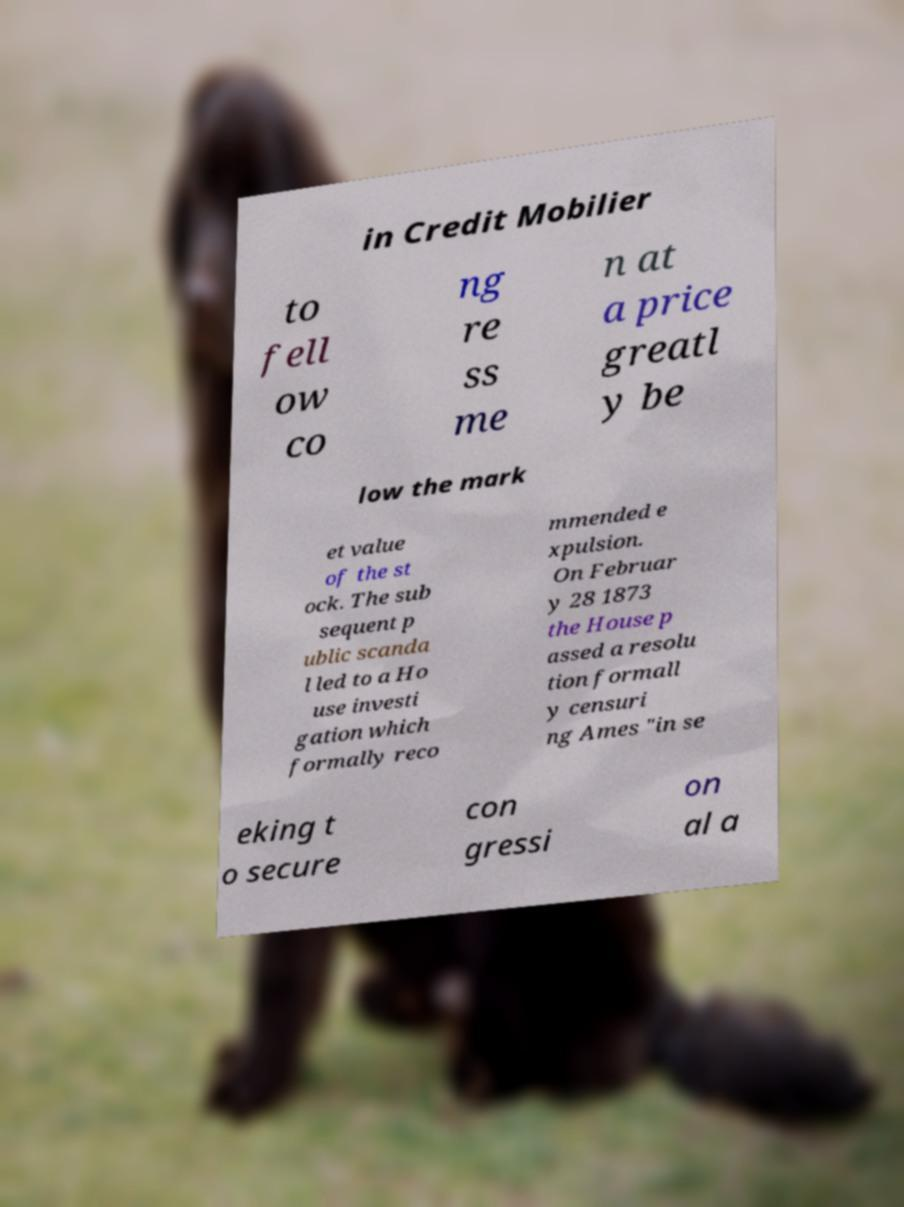Could you extract and type out the text from this image? in Credit Mobilier to fell ow co ng re ss me n at a price greatl y be low the mark et value of the st ock. The sub sequent p ublic scanda l led to a Ho use investi gation which formally reco mmended e xpulsion. On Februar y 28 1873 the House p assed a resolu tion formall y censuri ng Ames "in se eking t o secure con gressi on al a 